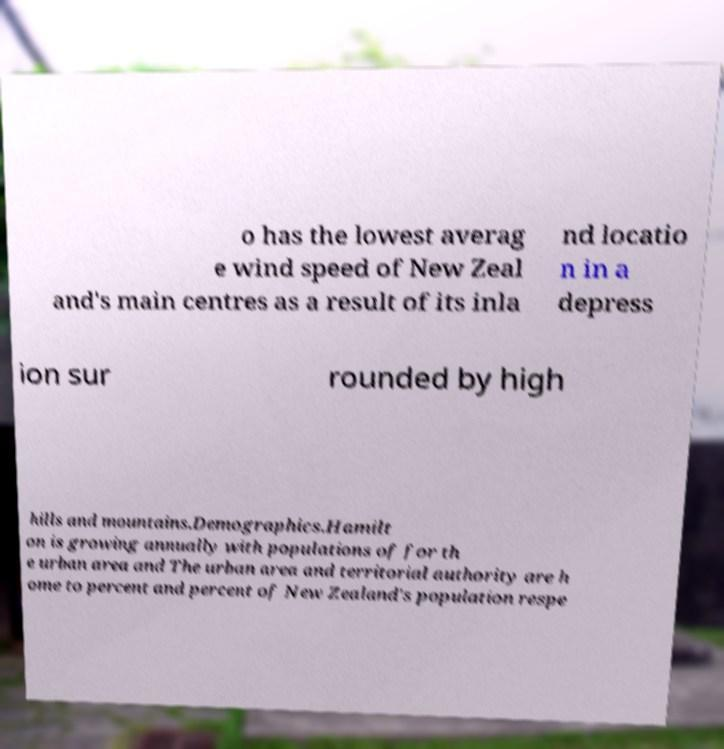Could you extract and type out the text from this image? o has the lowest averag e wind speed of New Zeal and's main centres as a result of its inla nd locatio n in a depress ion sur rounded by high hills and mountains.Demographics.Hamilt on is growing annually with populations of for th e urban area and The urban area and territorial authority are h ome to percent and percent of New Zealand's population respe 